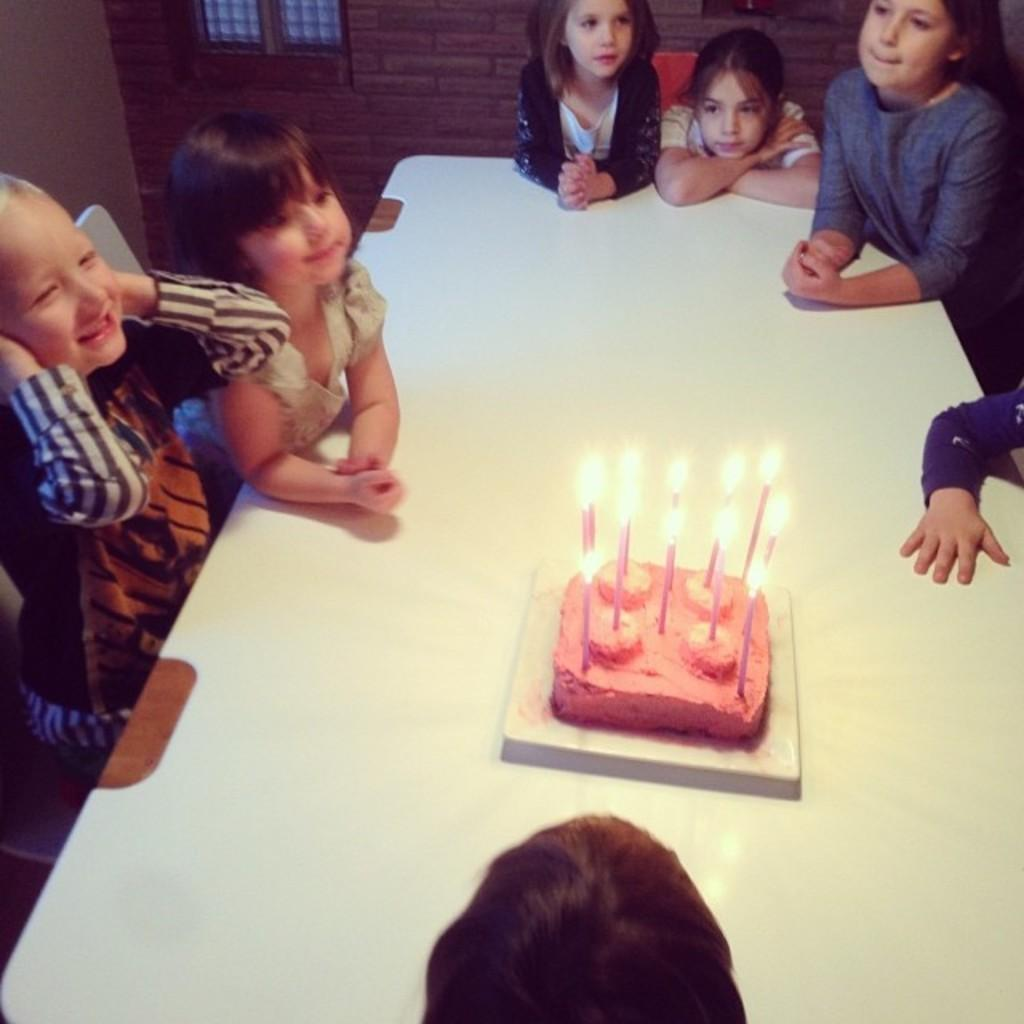What is the main subject of the image? The main subject of the image is a group of children. Where are the children located in the image? The children are sitting around a table in the image. What is on the table with the children? There is a cake on the table, and it has candles on it. How many trees can be seen in the image? There are no trees visible in the image; it features a group of children sitting around a table with a cake and candles. Are the children crying in the image? There is no indication in the image that the children are crying; they are sitting around a table with a cake and candles. 